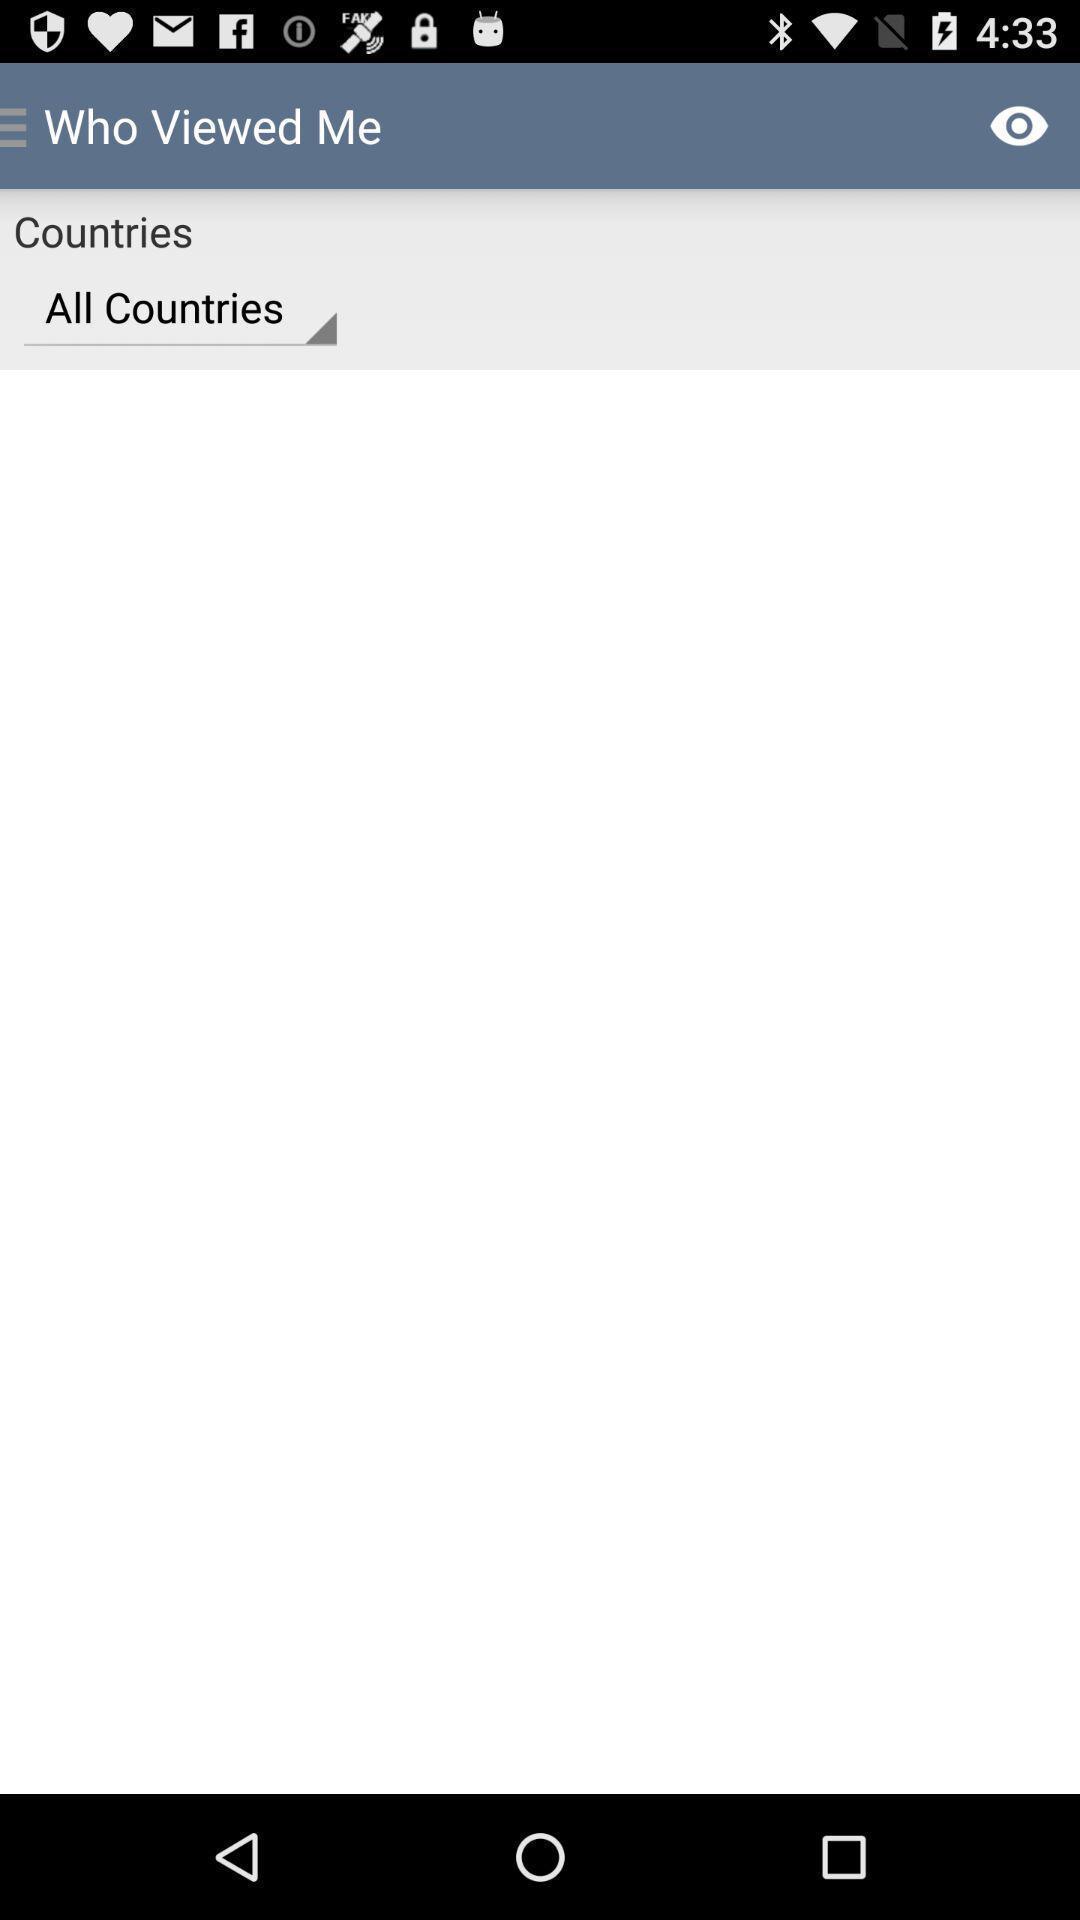Provide a description of this screenshot. Screen showing the blank page. 